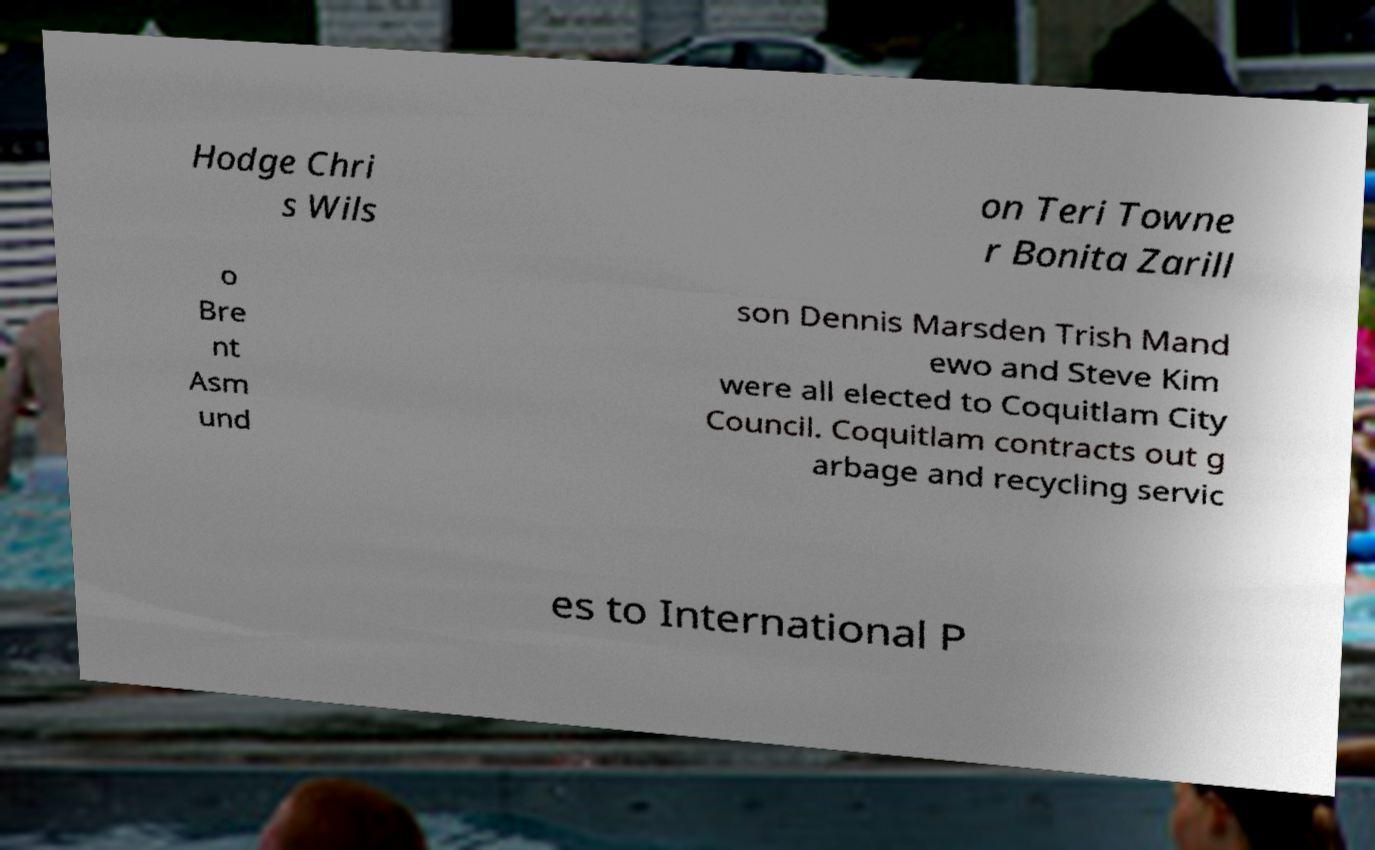Please read and relay the text visible in this image. What does it say? Hodge Chri s Wils on Teri Towne r Bonita Zarill o Bre nt Asm und son Dennis Marsden Trish Mand ewo and Steve Kim were all elected to Coquitlam City Council. Coquitlam contracts out g arbage and recycling servic es to International P 